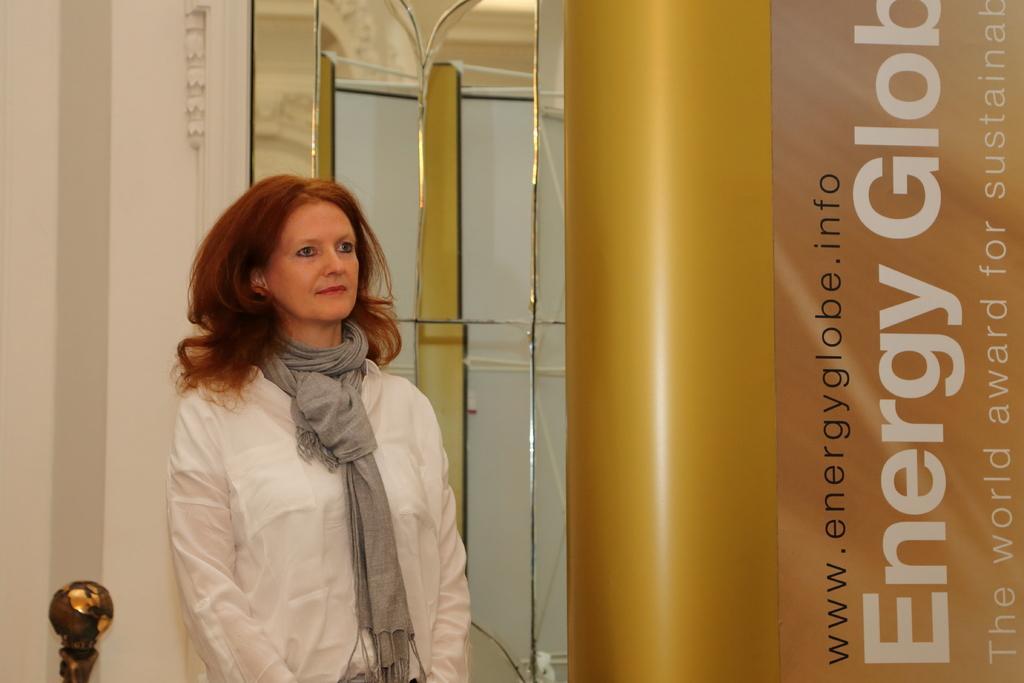In one or two sentences, can you explain what this image depicts? In the image we can see a lady. There is a mirror behind a lady. There is a banner at the right most of the image. 